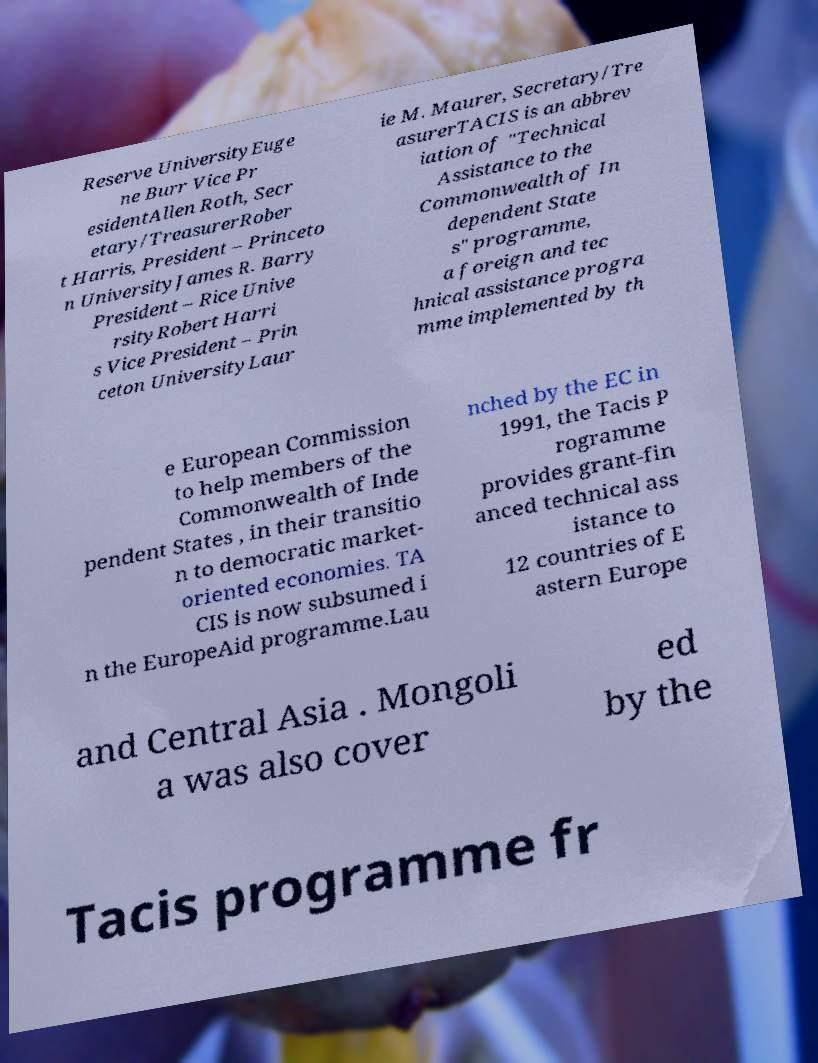Can you read and provide the text displayed in the image?This photo seems to have some interesting text. Can you extract and type it out for me? Reserve UniversityEuge ne Burr Vice Pr esidentAllen Roth, Secr etary/TreasurerRober t Harris, President – Princeto n UniversityJames R. Barry President – Rice Unive rsityRobert Harri s Vice President – Prin ceton UniversityLaur ie M. Maurer, Secretary/Tre asurerTACIS is an abbrev iation of "Technical Assistance to the Commonwealth of In dependent State s" programme, a foreign and tec hnical assistance progra mme implemented by th e European Commission to help members of the Commonwealth of Inde pendent States , in their transitio n to democratic market- oriented economies. TA CIS is now subsumed i n the EuropeAid programme.Lau nched by the EC in 1991, the Tacis P rogramme provides grant-fin anced technical ass istance to 12 countries of E astern Europe and Central Asia . Mongoli a was also cover ed by the Tacis programme fr 